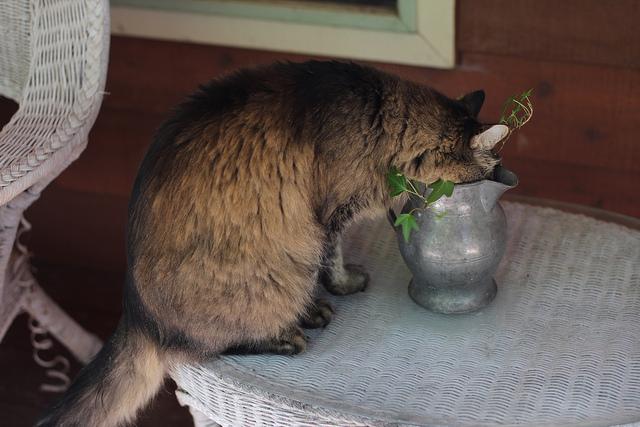What is the cat playing with?
Write a very short answer. Vase. Is this cat nosey?
Answer briefly. Yes. What is the cat putting his face in?
Concise answer only. Pitcher. What type of furniture is this?
Write a very short answer. Wicker. Where is the animals head?
Give a very brief answer. In vase. 